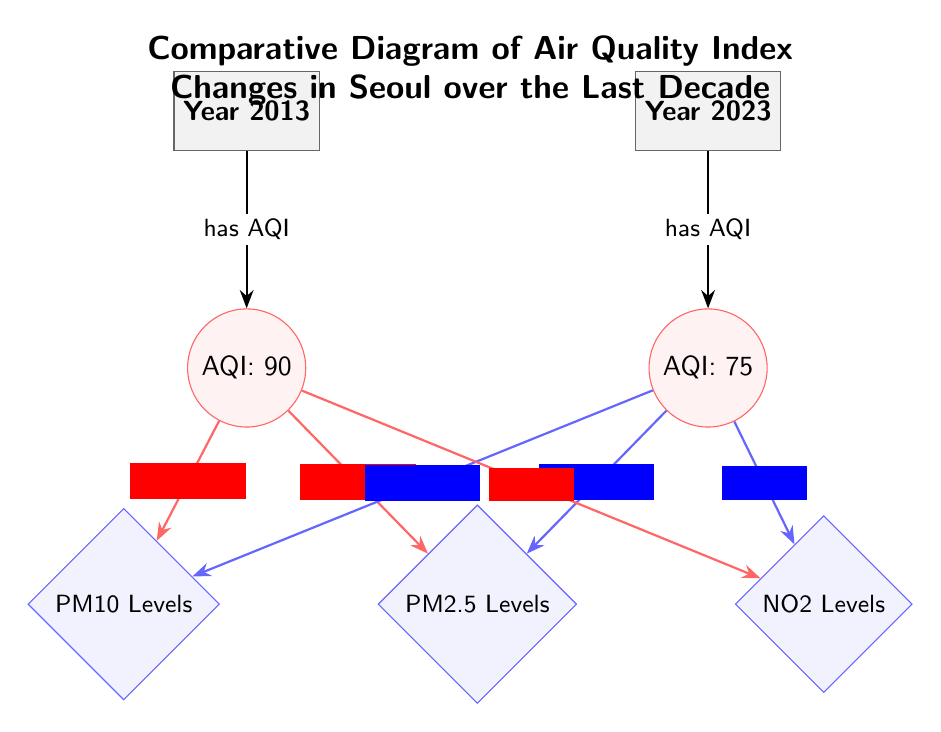What is the AQI in 2013? The diagram indicates that the AQI for the year 2013 is directly labeled as 90 in the AQI node below the year 2013.
Answer: 90 What is the AQI in 2023? Similarly, the diagram shows the AQI for the year 2023, which is labeled as 75 in the AQI node under the year 2023.
Answer: 75 What were the PM2.5 levels in 2013? The connection from the AQI for 2013 to the PM2.5 levels shows a value of 40 µg/m³ indicated in red color on the arrow.
Answer: 40 µg/m³ What were the PM2.5 levels in 2023? The connection from the AQI for 2023 to the PM2.5 levels shows a value of 30 µg/m³ indicated in blue color on the arrow.
Answer: 30 µg/m³ How did PM10 levels change from 2013 to 2023? To determine the change in PM10 levels, read the values connected to both years: it is 60 µg/m³ in 2013 and 50 µg/m³ in 2023. This indicates a decrease.
Answer: Decrease How much did the AQI improve from 2013 to 2023? The improvement is calculated by subtracting the AQI for 2023 (75) from the AQI for 2013 (90), resulting in a difference of 15.
Answer: 15 What is the total number of pollutants represented in the diagram? The diagram shows three pollutants: PM2.5, PM10, and NO2; thus, the total count is three.
Answer: 3 What pollutant had the highest concentration in 2013? By examining the pollutant levels for 2013: PM2.5 (40 µg/m³), PM10 (60 µg/m³), and NO2 (30 ppb), PM10 has the highest value at 60 µg/m³.
Answer: PM10 What pollutant had the highest concentration in 2023? The Year 2023 shows PM2.5 at 30 µg/m³, PM10 at 50 µg/m³, and NO2 at 20 ppb. PM10 retains the highest value at 50 µg/m³.
Answer: PM10 What overall trend can be seen in air quality from 2013 to 2023? The AQI has decreased from 90 to 75, and pollutant levels for PM2.5, PM10, and NO2 decreased as well, indicating an overall improvement in air quality.
Answer: Improvement 